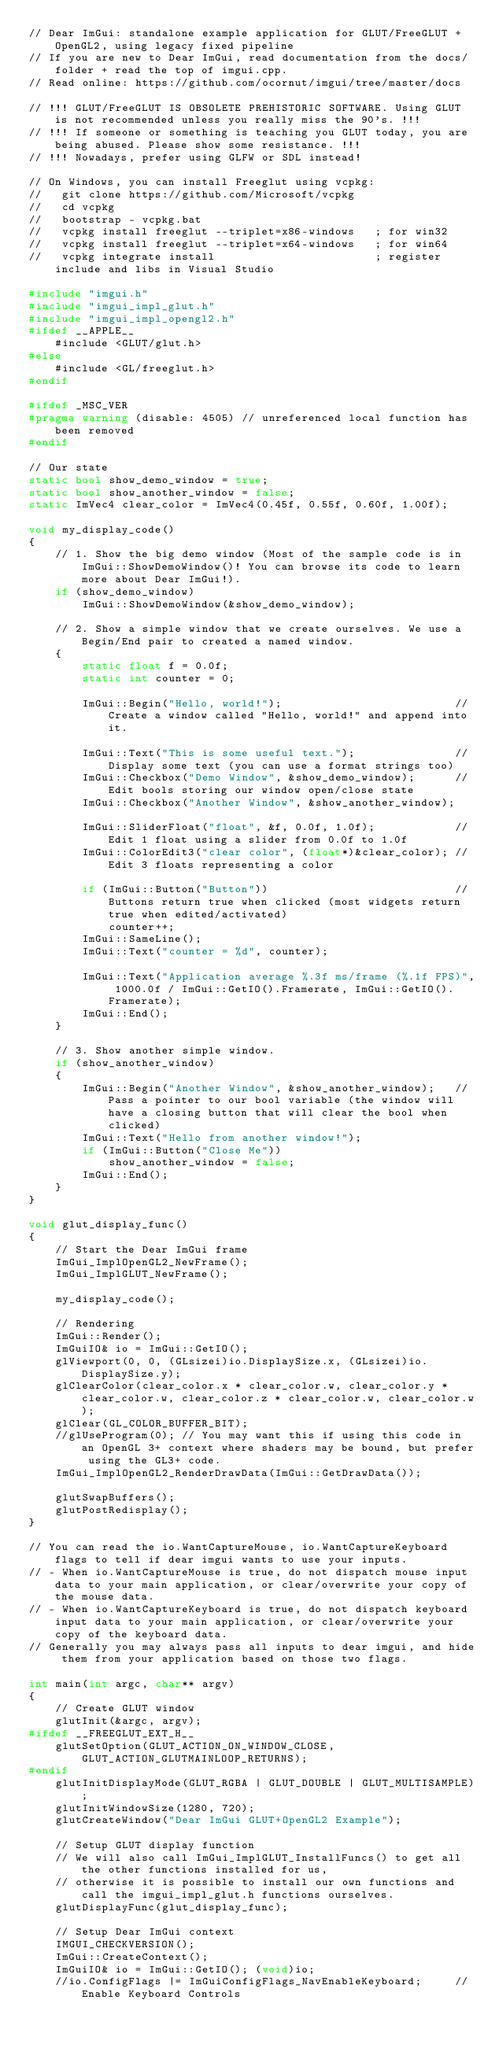<code> <loc_0><loc_0><loc_500><loc_500><_C++_>// Dear ImGui: standalone example application for GLUT/FreeGLUT + OpenGL2, using legacy fixed pipeline
// If you are new to Dear ImGui, read documentation from the docs/ folder + read the top of imgui.cpp.
// Read online: https://github.com/ocornut/imgui/tree/master/docs

// !!! GLUT/FreeGLUT IS OBSOLETE PREHISTORIC SOFTWARE. Using GLUT is not recommended unless you really miss the 90's. !!!
// !!! If someone or something is teaching you GLUT today, you are being abused. Please show some resistance. !!!
// !!! Nowadays, prefer using GLFW or SDL instead!

// On Windows, you can install Freeglut using vcpkg:
//   git clone https://github.com/Microsoft/vcpkg
//   cd vcpkg
//   bootstrap - vcpkg.bat
//   vcpkg install freeglut --triplet=x86-windows   ; for win32
//   vcpkg install freeglut --triplet=x64-windows   ; for win64
//   vcpkg integrate install                        ; register include and libs in Visual Studio

#include "imgui.h"
#include "imgui_impl_glut.h"
#include "imgui_impl_opengl2.h"
#ifdef __APPLE__
    #include <GLUT/glut.h>
#else
    #include <GL/freeglut.h>
#endif

#ifdef _MSC_VER
#pragma warning (disable: 4505) // unreferenced local function has been removed
#endif

// Our state
static bool show_demo_window = true;
static bool show_another_window = false;
static ImVec4 clear_color = ImVec4(0.45f, 0.55f, 0.60f, 1.00f);

void my_display_code()
{
    // 1. Show the big demo window (Most of the sample code is in ImGui::ShowDemoWindow()! You can browse its code to learn more about Dear ImGui!).
    if (show_demo_window)
        ImGui::ShowDemoWindow(&show_demo_window);

    // 2. Show a simple window that we create ourselves. We use a Begin/End pair to created a named window.
    {
        static float f = 0.0f;
        static int counter = 0;

        ImGui::Begin("Hello, world!");                          // Create a window called "Hello, world!" and append into it.

        ImGui::Text("This is some useful text.");               // Display some text (you can use a format strings too)
        ImGui::Checkbox("Demo Window", &show_demo_window);      // Edit bools storing our window open/close state
        ImGui::Checkbox("Another Window", &show_another_window);

        ImGui::SliderFloat("float", &f, 0.0f, 1.0f);            // Edit 1 float using a slider from 0.0f to 1.0f
        ImGui::ColorEdit3("clear color", (float*)&clear_color); // Edit 3 floats representing a color

        if (ImGui::Button("Button"))                            // Buttons return true when clicked (most widgets return true when edited/activated)
            counter++;
        ImGui::SameLine();
        ImGui::Text("counter = %d", counter);

        ImGui::Text("Application average %.3f ms/frame (%.1f FPS)", 1000.0f / ImGui::GetIO().Framerate, ImGui::GetIO().Framerate);
        ImGui::End();
    }

    // 3. Show another simple window.
    if (show_another_window)
    {
        ImGui::Begin("Another Window", &show_another_window);   // Pass a pointer to our bool variable (the window will have a closing button that will clear the bool when clicked)
        ImGui::Text("Hello from another window!");
        if (ImGui::Button("Close Me"))
            show_another_window = false;
        ImGui::End();
    }
}

void glut_display_func()
{
    // Start the Dear ImGui frame
    ImGui_ImplOpenGL2_NewFrame();
    ImGui_ImplGLUT_NewFrame();

    my_display_code();

    // Rendering
    ImGui::Render();
    ImGuiIO& io = ImGui::GetIO();
    glViewport(0, 0, (GLsizei)io.DisplaySize.x, (GLsizei)io.DisplaySize.y);
    glClearColor(clear_color.x * clear_color.w, clear_color.y * clear_color.w, clear_color.z * clear_color.w, clear_color.w);
    glClear(GL_COLOR_BUFFER_BIT);
    //glUseProgram(0); // You may want this if using this code in an OpenGL 3+ context where shaders may be bound, but prefer using the GL3+ code.
    ImGui_ImplOpenGL2_RenderDrawData(ImGui::GetDrawData());

    glutSwapBuffers();
    glutPostRedisplay();
}

// You can read the io.WantCaptureMouse, io.WantCaptureKeyboard flags to tell if dear imgui wants to use your inputs.
// - When io.WantCaptureMouse is true, do not dispatch mouse input data to your main application, or clear/overwrite your copy of the mouse data.
// - When io.WantCaptureKeyboard is true, do not dispatch keyboard input data to your main application, or clear/overwrite your copy of the keyboard data.
// Generally you may always pass all inputs to dear imgui, and hide them from your application based on those two flags.

int main(int argc, char** argv)
{
    // Create GLUT window
    glutInit(&argc, argv);
#ifdef __FREEGLUT_EXT_H__
    glutSetOption(GLUT_ACTION_ON_WINDOW_CLOSE, GLUT_ACTION_GLUTMAINLOOP_RETURNS);
#endif
    glutInitDisplayMode(GLUT_RGBA | GLUT_DOUBLE | GLUT_MULTISAMPLE);
    glutInitWindowSize(1280, 720);
    glutCreateWindow("Dear ImGui GLUT+OpenGL2 Example");

    // Setup GLUT display function
    // We will also call ImGui_ImplGLUT_InstallFuncs() to get all the other functions installed for us,
    // otherwise it is possible to install our own functions and call the imgui_impl_glut.h functions ourselves.
    glutDisplayFunc(glut_display_func);

    // Setup Dear ImGui context
    IMGUI_CHECKVERSION();
    ImGui::CreateContext();
    ImGuiIO& io = ImGui::GetIO(); (void)io;
    //io.ConfigFlags |= ImGuiConfigFlags_NavEnableKeyboard;     // Enable Keyboard Controls</code> 